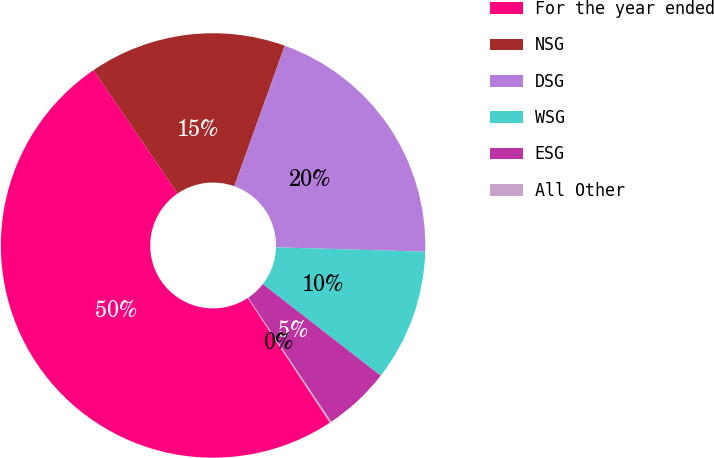Convert chart to OTSL. <chart><loc_0><loc_0><loc_500><loc_500><pie_chart><fcel>For the year ended<fcel>NSG<fcel>DSG<fcel>WSG<fcel>ESG<fcel>All Other<nl><fcel>49.75%<fcel>15.01%<fcel>19.98%<fcel>10.05%<fcel>5.09%<fcel>0.12%<nl></chart> 